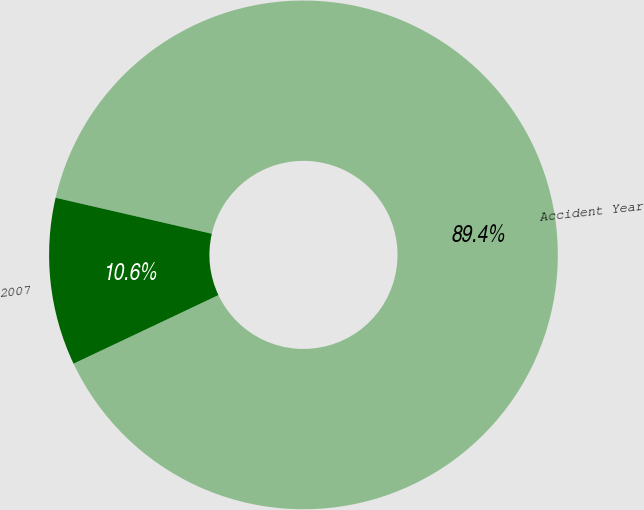Convert chart to OTSL. <chart><loc_0><loc_0><loc_500><loc_500><pie_chart><fcel>Accident Year<fcel>2007<nl><fcel>89.36%<fcel>10.64%<nl></chart> 